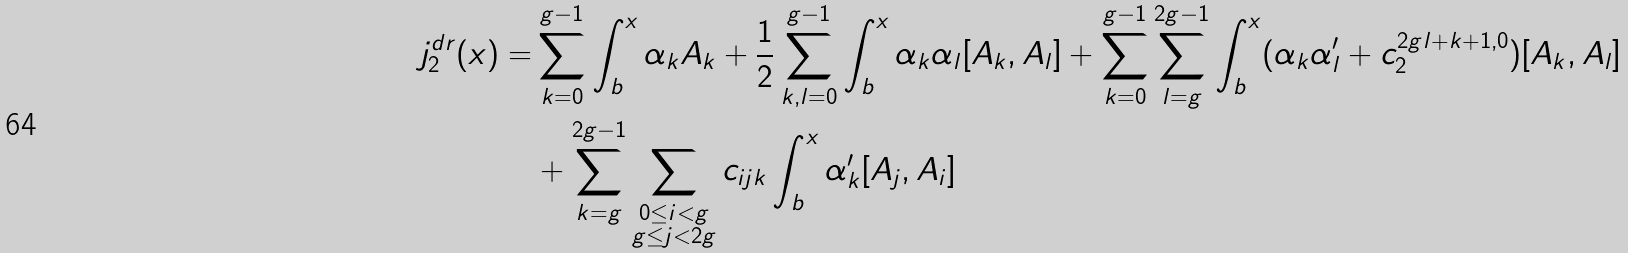<formula> <loc_0><loc_0><loc_500><loc_500>j ^ { d r } _ { 2 } ( x ) = & \sum _ { k = 0 } ^ { g - 1 } \int _ { b } ^ { x } \alpha _ { k } A _ { k } + \frac { 1 } { 2 } \sum _ { k , l = 0 } ^ { g - 1 } \int _ { b } ^ { x } \alpha _ { k } \alpha _ { l } [ A _ { k } , A _ { l } ] + \sum _ { k = 0 } ^ { g - 1 } \sum _ { l = g } ^ { 2 g - 1 } \int _ { b } ^ { x } ( \alpha _ { k } \alpha ^ { \prime } _ { l } + c _ { 2 } ^ { 2 g l + k + 1 , 0 } ) [ A _ { k } , A _ { l } ] \\ & + \sum _ { k = g } ^ { 2 g - 1 } \sum _ { \substack { 0 \leq i < g \\ g \leq j < 2 g } } c _ { i j k } \int _ { b } ^ { x } \alpha ^ { \prime } _ { k } [ A _ { j } , A _ { i } ]</formula> 